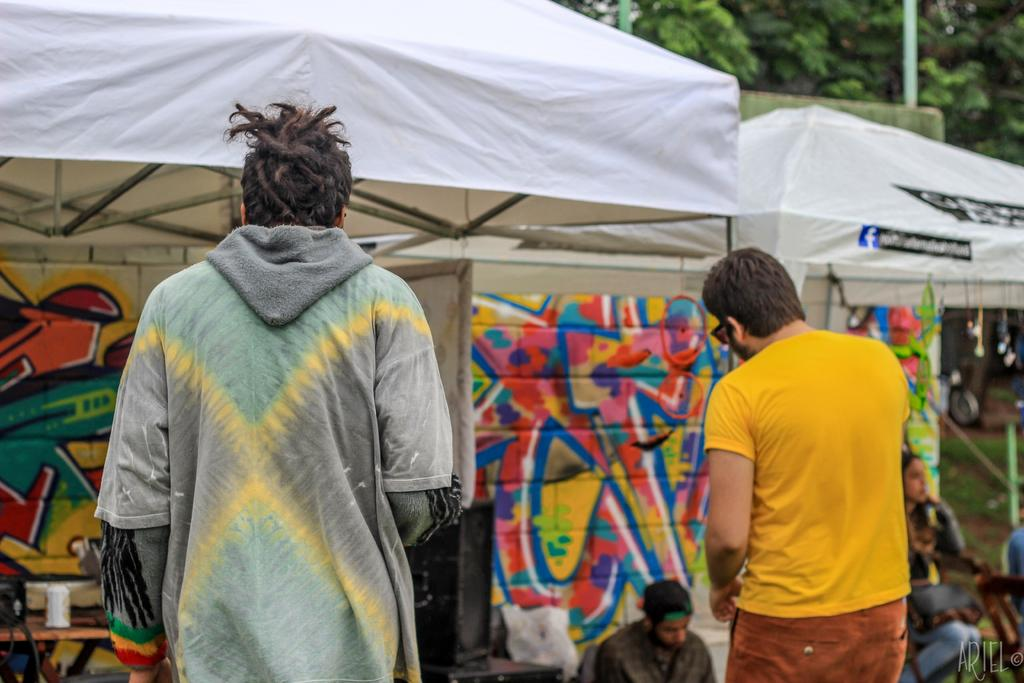How many people are present in the image? There are two people standing in the center of the image. What can be seen in the background of the image? There are stalls and trees visible in the background of the image. What type of lizards can be seen talking to each other in the image? There are no lizards present in the image, and therefore no such conversation can be observed. 